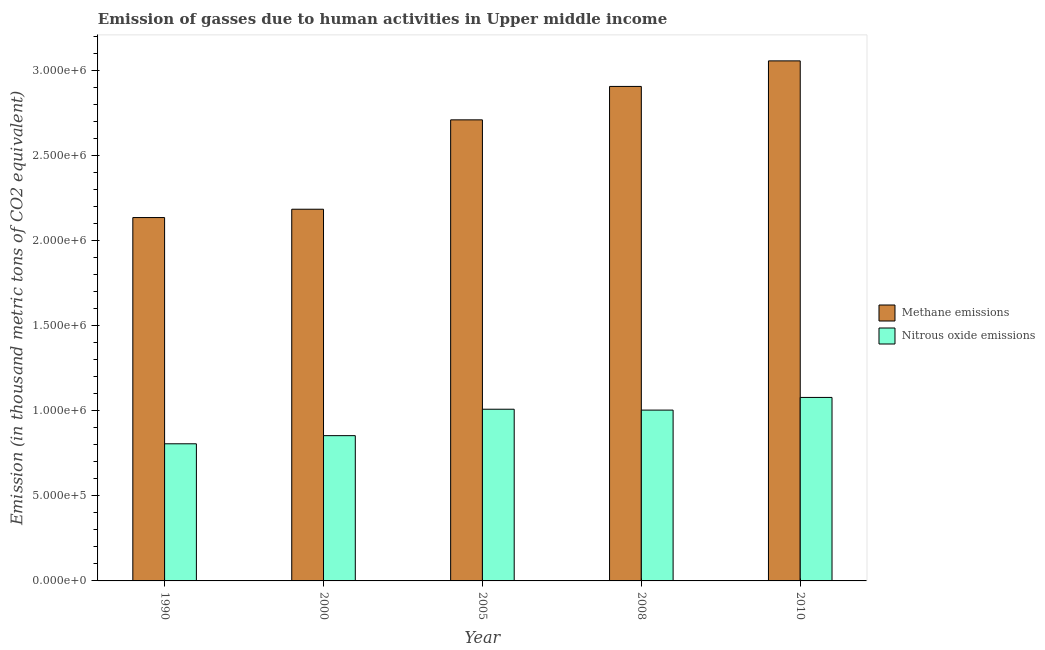How many groups of bars are there?
Your answer should be very brief. 5. Are the number of bars per tick equal to the number of legend labels?
Keep it short and to the point. Yes. How many bars are there on the 4th tick from the right?
Give a very brief answer. 2. What is the amount of nitrous oxide emissions in 1990?
Provide a succinct answer. 8.06e+05. Across all years, what is the maximum amount of methane emissions?
Offer a very short reply. 3.06e+06. Across all years, what is the minimum amount of nitrous oxide emissions?
Your answer should be compact. 8.06e+05. What is the total amount of methane emissions in the graph?
Provide a succinct answer. 1.30e+07. What is the difference between the amount of nitrous oxide emissions in 2000 and that in 2008?
Offer a very short reply. -1.50e+05. What is the difference between the amount of nitrous oxide emissions in 2000 and the amount of methane emissions in 2010?
Keep it short and to the point. -2.24e+05. What is the average amount of methane emissions per year?
Make the answer very short. 2.60e+06. In how many years, is the amount of methane emissions greater than 2100000 thousand metric tons?
Offer a very short reply. 5. What is the ratio of the amount of methane emissions in 1990 to that in 2010?
Your answer should be compact. 0.7. What is the difference between the highest and the second highest amount of nitrous oxide emissions?
Provide a short and direct response. 6.92e+04. What is the difference between the highest and the lowest amount of methane emissions?
Offer a terse response. 9.20e+05. What does the 2nd bar from the left in 1990 represents?
Give a very brief answer. Nitrous oxide emissions. What does the 1st bar from the right in 2008 represents?
Offer a terse response. Nitrous oxide emissions. Are all the bars in the graph horizontal?
Your answer should be very brief. No. How many years are there in the graph?
Provide a short and direct response. 5. What is the difference between two consecutive major ticks on the Y-axis?
Give a very brief answer. 5.00e+05. Does the graph contain any zero values?
Provide a succinct answer. No. Where does the legend appear in the graph?
Your answer should be compact. Center right. How many legend labels are there?
Make the answer very short. 2. How are the legend labels stacked?
Provide a short and direct response. Vertical. What is the title of the graph?
Your answer should be very brief. Emission of gasses due to human activities in Upper middle income. Does "Research and Development" appear as one of the legend labels in the graph?
Your answer should be compact. No. What is the label or title of the X-axis?
Keep it short and to the point. Year. What is the label or title of the Y-axis?
Offer a terse response. Emission (in thousand metric tons of CO2 equivalent). What is the Emission (in thousand metric tons of CO2 equivalent) in Methane emissions in 1990?
Keep it short and to the point. 2.13e+06. What is the Emission (in thousand metric tons of CO2 equivalent) in Nitrous oxide emissions in 1990?
Make the answer very short. 8.06e+05. What is the Emission (in thousand metric tons of CO2 equivalent) of Methane emissions in 2000?
Your answer should be very brief. 2.18e+06. What is the Emission (in thousand metric tons of CO2 equivalent) in Nitrous oxide emissions in 2000?
Your answer should be very brief. 8.54e+05. What is the Emission (in thousand metric tons of CO2 equivalent) in Methane emissions in 2005?
Your answer should be very brief. 2.71e+06. What is the Emission (in thousand metric tons of CO2 equivalent) of Nitrous oxide emissions in 2005?
Your answer should be very brief. 1.01e+06. What is the Emission (in thousand metric tons of CO2 equivalent) of Methane emissions in 2008?
Make the answer very short. 2.91e+06. What is the Emission (in thousand metric tons of CO2 equivalent) in Nitrous oxide emissions in 2008?
Make the answer very short. 1.00e+06. What is the Emission (in thousand metric tons of CO2 equivalent) in Methane emissions in 2010?
Give a very brief answer. 3.06e+06. What is the Emission (in thousand metric tons of CO2 equivalent) in Nitrous oxide emissions in 2010?
Give a very brief answer. 1.08e+06. Across all years, what is the maximum Emission (in thousand metric tons of CO2 equivalent) in Methane emissions?
Offer a very short reply. 3.06e+06. Across all years, what is the maximum Emission (in thousand metric tons of CO2 equivalent) of Nitrous oxide emissions?
Offer a very short reply. 1.08e+06. Across all years, what is the minimum Emission (in thousand metric tons of CO2 equivalent) in Methane emissions?
Provide a succinct answer. 2.13e+06. Across all years, what is the minimum Emission (in thousand metric tons of CO2 equivalent) of Nitrous oxide emissions?
Your response must be concise. 8.06e+05. What is the total Emission (in thousand metric tons of CO2 equivalent) of Methane emissions in the graph?
Ensure brevity in your answer.  1.30e+07. What is the total Emission (in thousand metric tons of CO2 equivalent) in Nitrous oxide emissions in the graph?
Offer a terse response. 4.75e+06. What is the difference between the Emission (in thousand metric tons of CO2 equivalent) in Methane emissions in 1990 and that in 2000?
Your answer should be very brief. -4.89e+04. What is the difference between the Emission (in thousand metric tons of CO2 equivalent) of Nitrous oxide emissions in 1990 and that in 2000?
Your answer should be very brief. -4.79e+04. What is the difference between the Emission (in thousand metric tons of CO2 equivalent) of Methane emissions in 1990 and that in 2005?
Your answer should be compact. -5.74e+05. What is the difference between the Emission (in thousand metric tons of CO2 equivalent) of Nitrous oxide emissions in 1990 and that in 2005?
Ensure brevity in your answer.  -2.03e+05. What is the difference between the Emission (in thousand metric tons of CO2 equivalent) in Methane emissions in 1990 and that in 2008?
Offer a terse response. -7.70e+05. What is the difference between the Emission (in thousand metric tons of CO2 equivalent) in Nitrous oxide emissions in 1990 and that in 2008?
Provide a short and direct response. -1.98e+05. What is the difference between the Emission (in thousand metric tons of CO2 equivalent) in Methane emissions in 1990 and that in 2010?
Your answer should be very brief. -9.20e+05. What is the difference between the Emission (in thousand metric tons of CO2 equivalent) in Nitrous oxide emissions in 1990 and that in 2010?
Make the answer very short. -2.72e+05. What is the difference between the Emission (in thousand metric tons of CO2 equivalent) in Methane emissions in 2000 and that in 2005?
Your answer should be compact. -5.25e+05. What is the difference between the Emission (in thousand metric tons of CO2 equivalent) of Nitrous oxide emissions in 2000 and that in 2005?
Your answer should be very brief. -1.55e+05. What is the difference between the Emission (in thousand metric tons of CO2 equivalent) in Methane emissions in 2000 and that in 2008?
Make the answer very short. -7.21e+05. What is the difference between the Emission (in thousand metric tons of CO2 equivalent) in Nitrous oxide emissions in 2000 and that in 2008?
Ensure brevity in your answer.  -1.50e+05. What is the difference between the Emission (in thousand metric tons of CO2 equivalent) of Methane emissions in 2000 and that in 2010?
Give a very brief answer. -8.72e+05. What is the difference between the Emission (in thousand metric tons of CO2 equivalent) in Nitrous oxide emissions in 2000 and that in 2010?
Offer a terse response. -2.24e+05. What is the difference between the Emission (in thousand metric tons of CO2 equivalent) of Methane emissions in 2005 and that in 2008?
Ensure brevity in your answer.  -1.96e+05. What is the difference between the Emission (in thousand metric tons of CO2 equivalent) of Nitrous oxide emissions in 2005 and that in 2008?
Offer a very short reply. 5159.9. What is the difference between the Emission (in thousand metric tons of CO2 equivalent) in Methane emissions in 2005 and that in 2010?
Provide a short and direct response. -3.46e+05. What is the difference between the Emission (in thousand metric tons of CO2 equivalent) of Nitrous oxide emissions in 2005 and that in 2010?
Make the answer very short. -6.92e+04. What is the difference between the Emission (in thousand metric tons of CO2 equivalent) in Methane emissions in 2008 and that in 2010?
Your answer should be very brief. -1.50e+05. What is the difference between the Emission (in thousand metric tons of CO2 equivalent) of Nitrous oxide emissions in 2008 and that in 2010?
Your answer should be compact. -7.44e+04. What is the difference between the Emission (in thousand metric tons of CO2 equivalent) in Methane emissions in 1990 and the Emission (in thousand metric tons of CO2 equivalent) in Nitrous oxide emissions in 2000?
Offer a very short reply. 1.28e+06. What is the difference between the Emission (in thousand metric tons of CO2 equivalent) in Methane emissions in 1990 and the Emission (in thousand metric tons of CO2 equivalent) in Nitrous oxide emissions in 2005?
Your answer should be compact. 1.13e+06. What is the difference between the Emission (in thousand metric tons of CO2 equivalent) of Methane emissions in 1990 and the Emission (in thousand metric tons of CO2 equivalent) of Nitrous oxide emissions in 2008?
Give a very brief answer. 1.13e+06. What is the difference between the Emission (in thousand metric tons of CO2 equivalent) of Methane emissions in 1990 and the Emission (in thousand metric tons of CO2 equivalent) of Nitrous oxide emissions in 2010?
Your response must be concise. 1.06e+06. What is the difference between the Emission (in thousand metric tons of CO2 equivalent) of Methane emissions in 2000 and the Emission (in thousand metric tons of CO2 equivalent) of Nitrous oxide emissions in 2005?
Keep it short and to the point. 1.17e+06. What is the difference between the Emission (in thousand metric tons of CO2 equivalent) in Methane emissions in 2000 and the Emission (in thousand metric tons of CO2 equivalent) in Nitrous oxide emissions in 2008?
Make the answer very short. 1.18e+06. What is the difference between the Emission (in thousand metric tons of CO2 equivalent) of Methane emissions in 2000 and the Emission (in thousand metric tons of CO2 equivalent) of Nitrous oxide emissions in 2010?
Offer a terse response. 1.11e+06. What is the difference between the Emission (in thousand metric tons of CO2 equivalent) in Methane emissions in 2005 and the Emission (in thousand metric tons of CO2 equivalent) in Nitrous oxide emissions in 2008?
Make the answer very short. 1.71e+06. What is the difference between the Emission (in thousand metric tons of CO2 equivalent) of Methane emissions in 2005 and the Emission (in thousand metric tons of CO2 equivalent) of Nitrous oxide emissions in 2010?
Give a very brief answer. 1.63e+06. What is the difference between the Emission (in thousand metric tons of CO2 equivalent) in Methane emissions in 2008 and the Emission (in thousand metric tons of CO2 equivalent) in Nitrous oxide emissions in 2010?
Offer a terse response. 1.83e+06. What is the average Emission (in thousand metric tons of CO2 equivalent) in Methane emissions per year?
Provide a succinct answer. 2.60e+06. What is the average Emission (in thousand metric tons of CO2 equivalent) of Nitrous oxide emissions per year?
Give a very brief answer. 9.50e+05. In the year 1990, what is the difference between the Emission (in thousand metric tons of CO2 equivalent) of Methane emissions and Emission (in thousand metric tons of CO2 equivalent) of Nitrous oxide emissions?
Provide a short and direct response. 1.33e+06. In the year 2000, what is the difference between the Emission (in thousand metric tons of CO2 equivalent) of Methane emissions and Emission (in thousand metric tons of CO2 equivalent) of Nitrous oxide emissions?
Provide a short and direct response. 1.33e+06. In the year 2005, what is the difference between the Emission (in thousand metric tons of CO2 equivalent) in Methane emissions and Emission (in thousand metric tons of CO2 equivalent) in Nitrous oxide emissions?
Your answer should be very brief. 1.70e+06. In the year 2008, what is the difference between the Emission (in thousand metric tons of CO2 equivalent) in Methane emissions and Emission (in thousand metric tons of CO2 equivalent) in Nitrous oxide emissions?
Your answer should be compact. 1.90e+06. In the year 2010, what is the difference between the Emission (in thousand metric tons of CO2 equivalent) in Methane emissions and Emission (in thousand metric tons of CO2 equivalent) in Nitrous oxide emissions?
Provide a succinct answer. 1.98e+06. What is the ratio of the Emission (in thousand metric tons of CO2 equivalent) of Methane emissions in 1990 to that in 2000?
Offer a very short reply. 0.98. What is the ratio of the Emission (in thousand metric tons of CO2 equivalent) in Nitrous oxide emissions in 1990 to that in 2000?
Provide a short and direct response. 0.94. What is the ratio of the Emission (in thousand metric tons of CO2 equivalent) in Methane emissions in 1990 to that in 2005?
Your answer should be compact. 0.79. What is the ratio of the Emission (in thousand metric tons of CO2 equivalent) of Nitrous oxide emissions in 1990 to that in 2005?
Give a very brief answer. 0.8. What is the ratio of the Emission (in thousand metric tons of CO2 equivalent) of Methane emissions in 1990 to that in 2008?
Offer a terse response. 0.73. What is the ratio of the Emission (in thousand metric tons of CO2 equivalent) of Nitrous oxide emissions in 1990 to that in 2008?
Keep it short and to the point. 0.8. What is the ratio of the Emission (in thousand metric tons of CO2 equivalent) of Methane emissions in 1990 to that in 2010?
Your answer should be compact. 0.7. What is the ratio of the Emission (in thousand metric tons of CO2 equivalent) in Nitrous oxide emissions in 1990 to that in 2010?
Your answer should be very brief. 0.75. What is the ratio of the Emission (in thousand metric tons of CO2 equivalent) of Methane emissions in 2000 to that in 2005?
Your answer should be compact. 0.81. What is the ratio of the Emission (in thousand metric tons of CO2 equivalent) of Nitrous oxide emissions in 2000 to that in 2005?
Offer a terse response. 0.85. What is the ratio of the Emission (in thousand metric tons of CO2 equivalent) of Methane emissions in 2000 to that in 2008?
Offer a terse response. 0.75. What is the ratio of the Emission (in thousand metric tons of CO2 equivalent) in Nitrous oxide emissions in 2000 to that in 2008?
Your answer should be very brief. 0.85. What is the ratio of the Emission (in thousand metric tons of CO2 equivalent) in Methane emissions in 2000 to that in 2010?
Ensure brevity in your answer.  0.71. What is the ratio of the Emission (in thousand metric tons of CO2 equivalent) in Nitrous oxide emissions in 2000 to that in 2010?
Your response must be concise. 0.79. What is the ratio of the Emission (in thousand metric tons of CO2 equivalent) in Methane emissions in 2005 to that in 2008?
Offer a very short reply. 0.93. What is the ratio of the Emission (in thousand metric tons of CO2 equivalent) of Methane emissions in 2005 to that in 2010?
Give a very brief answer. 0.89. What is the ratio of the Emission (in thousand metric tons of CO2 equivalent) in Nitrous oxide emissions in 2005 to that in 2010?
Offer a terse response. 0.94. What is the ratio of the Emission (in thousand metric tons of CO2 equivalent) in Methane emissions in 2008 to that in 2010?
Your answer should be very brief. 0.95. What is the ratio of the Emission (in thousand metric tons of CO2 equivalent) in Nitrous oxide emissions in 2008 to that in 2010?
Offer a terse response. 0.93. What is the difference between the highest and the second highest Emission (in thousand metric tons of CO2 equivalent) in Methane emissions?
Provide a short and direct response. 1.50e+05. What is the difference between the highest and the second highest Emission (in thousand metric tons of CO2 equivalent) of Nitrous oxide emissions?
Offer a terse response. 6.92e+04. What is the difference between the highest and the lowest Emission (in thousand metric tons of CO2 equivalent) in Methane emissions?
Your answer should be compact. 9.20e+05. What is the difference between the highest and the lowest Emission (in thousand metric tons of CO2 equivalent) of Nitrous oxide emissions?
Your response must be concise. 2.72e+05. 